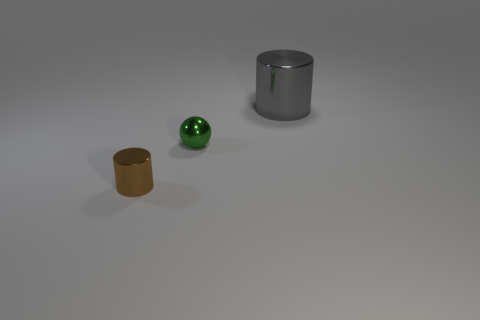Add 1 big yellow cylinders. How many objects exist? 4 Subtract 1 spheres. How many spheres are left? 0 Subtract all gray cylinders. How many cylinders are left? 1 Subtract all cylinders. How many objects are left? 1 Subtract all brown cylinders. Subtract all brown cubes. How many cylinders are left? 1 Subtract all brown cubes. How many gray cylinders are left? 1 Subtract all small metal spheres. Subtract all big gray things. How many objects are left? 1 Add 1 gray cylinders. How many gray cylinders are left? 2 Add 1 tiny gray things. How many tiny gray things exist? 1 Subtract 0 red blocks. How many objects are left? 3 